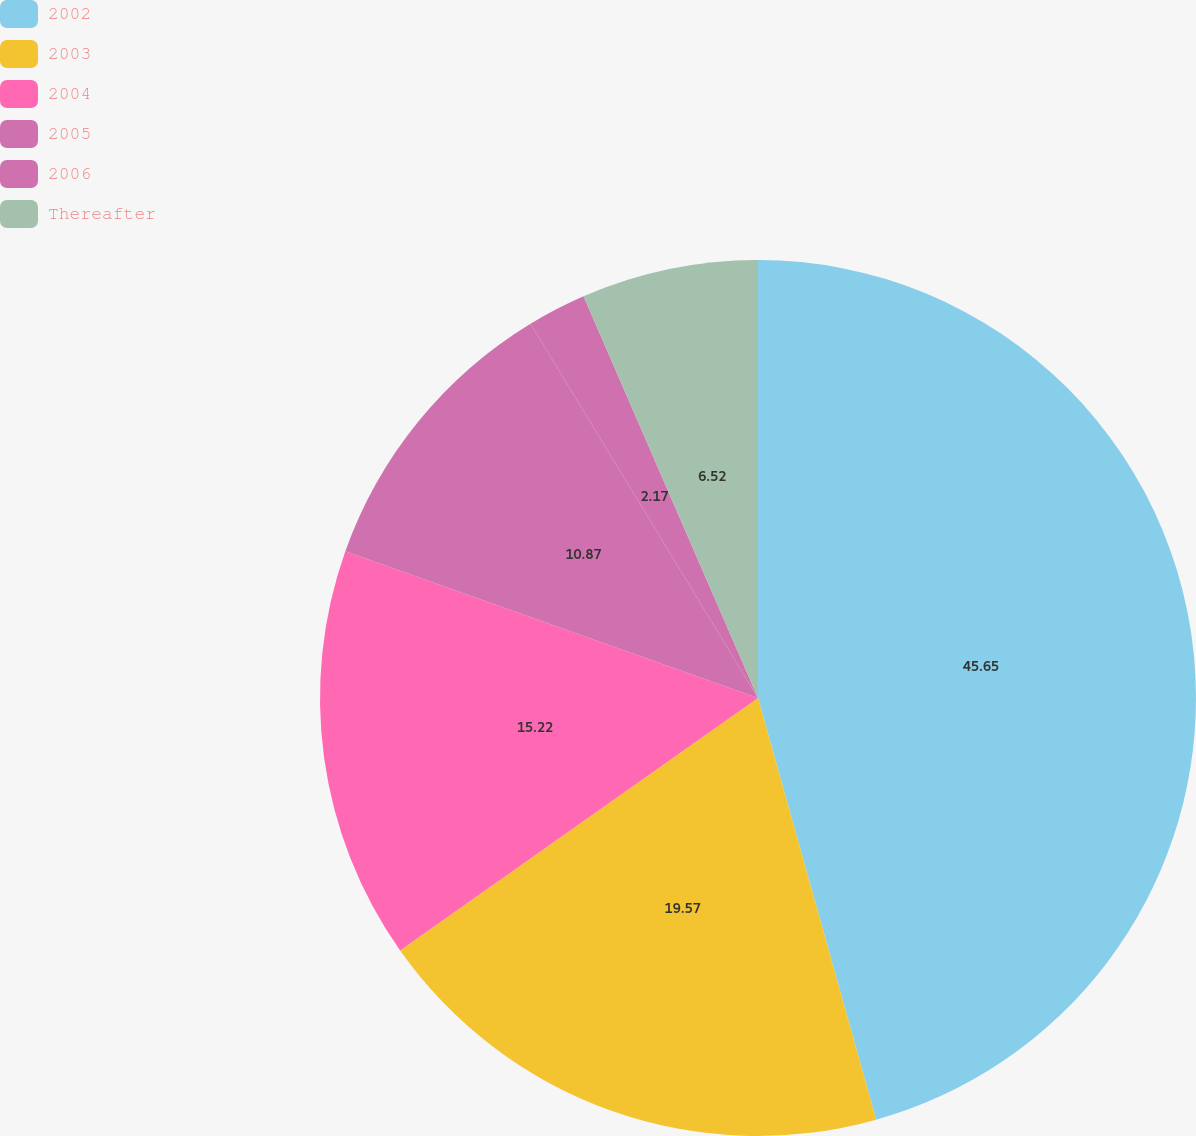Convert chart. <chart><loc_0><loc_0><loc_500><loc_500><pie_chart><fcel>2002<fcel>2003<fcel>2004<fcel>2005<fcel>2006<fcel>Thereafter<nl><fcel>45.65%<fcel>19.57%<fcel>15.22%<fcel>10.87%<fcel>2.17%<fcel>6.52%<nl></chart> 